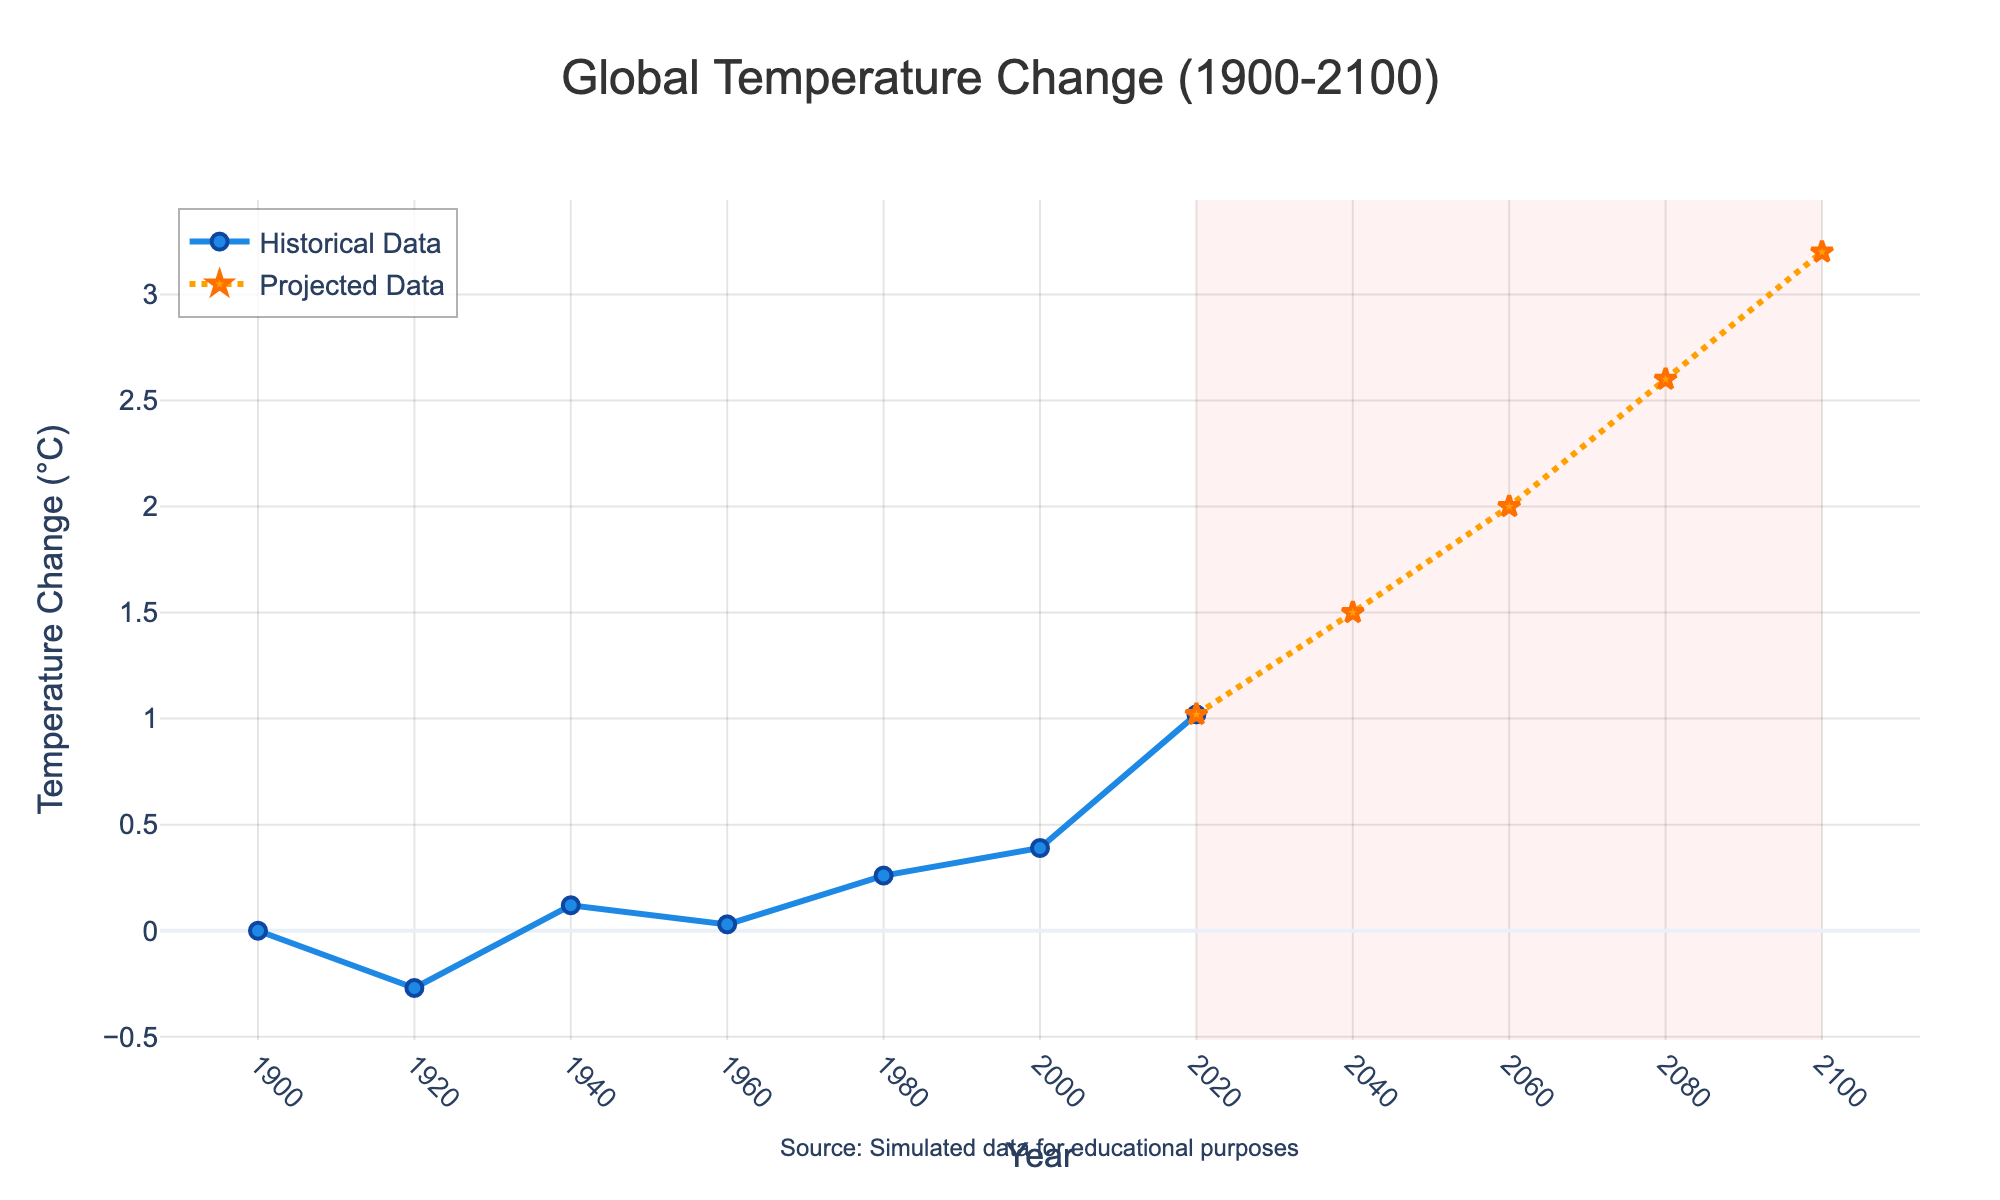What is the temperature change in 1980 compared to 1940? The temperature change in 1980 is 0.26°C, and in 1940, it is 0.12°C. The difference is 0.26 - 0.12 = 0.14°C.
Answer: 0.14°C How much is the temperature projected to increase from 2020 to 2100? The temperature change in 2020 is 1.02°C, and in 2100 it is projected to be 3.2°C. The increase is 3.2 - 1.02 = 2.18°C.
Answer: 2.18°C In what period does the temperature change exceed 1°C for the first time? The temperature change exceeds 1°C for the first time in the year 2020.
Answer: 2020 Compare the temperature change in 2000 to 2020. How much has it increased? The temperature change in 2000 is 0.39°C, and in 2020 it is 1.02°C. The increase is 1.02 - 0.39 = 0.63°C.
Answer: 0.63°C What is the average temperature change from 1900 to 1980? The temperature changes from 1900 to 1980 are 0.0, -0.27, 0.12, 0.03, 0.26. The average is (0.0 - 0.27 + 0.12 + 0.03 + 0.26) / 5 = 0.028°C.
Answer: 0.028°C What is the color of the line representing the projected data? The line representing the projected data is orange.
Answer: Orange During which decades does the plot show the most rapid increase in temperature? The most rapid increase in temperature is observed from 2020 to 2100, as indicated by the steep slope and projections showing a significant rise.
Answer: 2020-2100 Compare the temperature change in 1960 to that in 1980. Which year had a higher temperature change and by how much? The temperature change in 1960 is 0.03°C, and in 1980 it is 0.26°C. 1980 had a higher temperature change. The difference is 0.26 - 0.03 = 0.23°C.
Answer: 1980 by 0.23°C At what year does the shaded area indicating future projections start? The shaded area for future projections starts from the year 2020.
Answer: 2020 